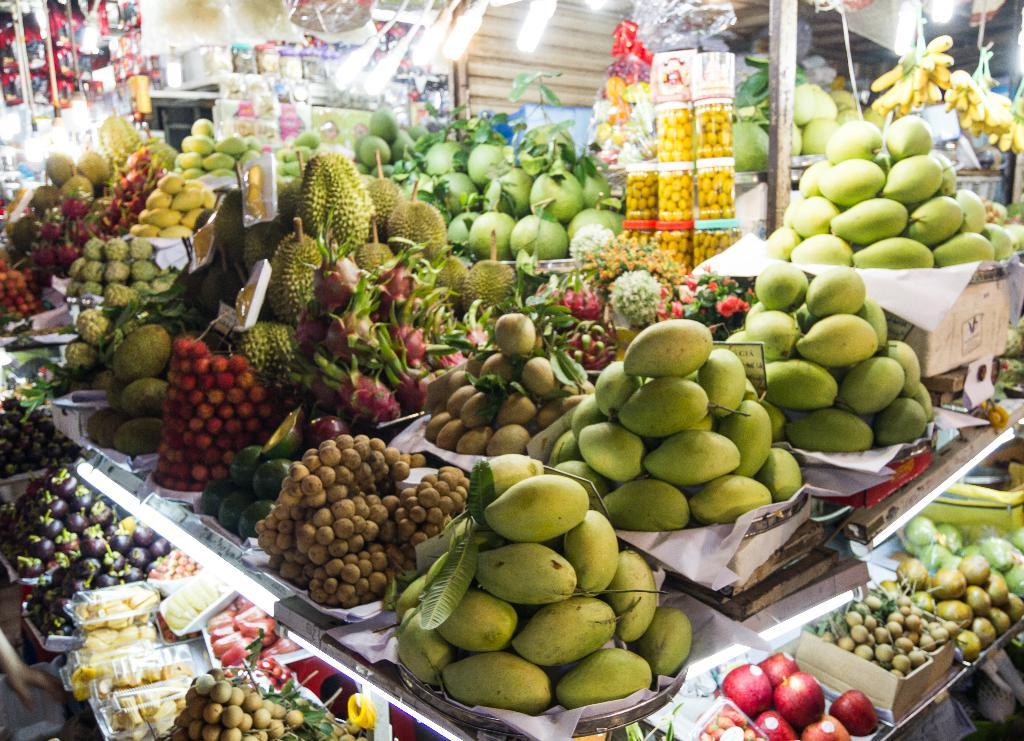What types of food can be seen in the image? There are different types of fruits in the image. Where are the fruits located in the image? The fruits are located in the middle of the image. Who is sitting on the throne in the image? There is no throne present in the image; it features different types of fruits. How many divisions can be seen in the image? There is no division or segmentation visible in the image, as it only shows different types of fruits. 